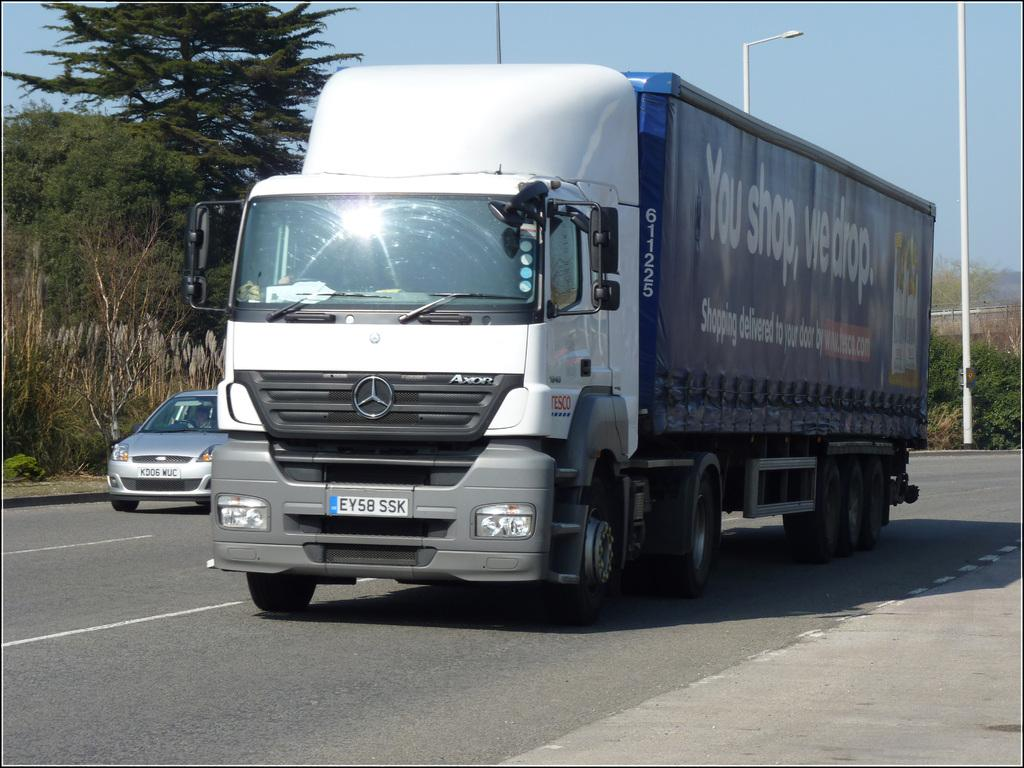What type of vehicles are present in the image? There is a truck and a car in the image. What are the vehicles doing in the image? The truck and car are moving on the road. What type of lighting is present in the image? There are pole lights in the image. What type of vegetation is present in the image? There are trees in the image. What is the color of the sky in the image? The sky is blue in the image. How many dogs are playing rhythm with your uncle in the image? There are no dogs or your uncle present in the image. 